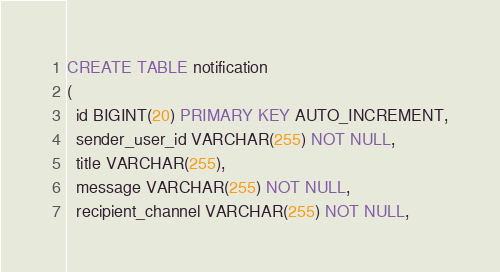<code> <loc_0><loc_0><loc_500><loc_500><_SQL_>CREATE TABLE notification
(
  id BIGINT(20) PRIMARY KEY AUTO_INCREMENT,
  sender_user_id VARCHAR(255) NOT NULL,
  title VARCHAR(255),
  message VARCHAR(255) NOT NULL,
  recipient_channel VARCHAR(255) NOT NULL,</code> 